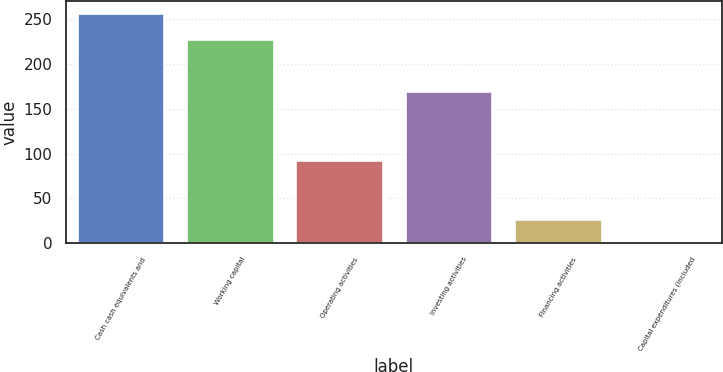Convert chart to OTSL. <chart><loc_0><loc_0><loc_500><loc_500><bar_chart><fcel>Cash cash equivalents and<fcel>Working capital<fcel>Operating activities<fcel>Investing activities<fcel>Financing activities<fcel>Capital expenditures (included<nl><fcel>257.3<fcel>227.8<fcel>92.7<fcel>170.4<fcel>26.81<fcel>1.2<nl></chart> 